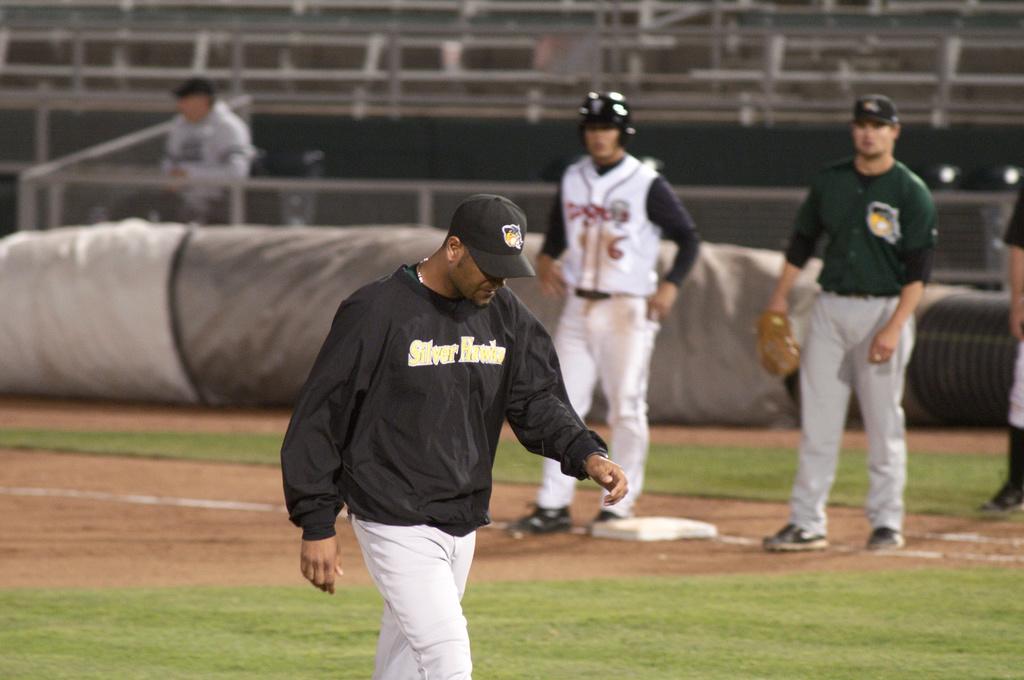What is on the black sweat shirt?
Give a very brief answer. Silver. Is this the major league?
Provide a short and direct response. No. 